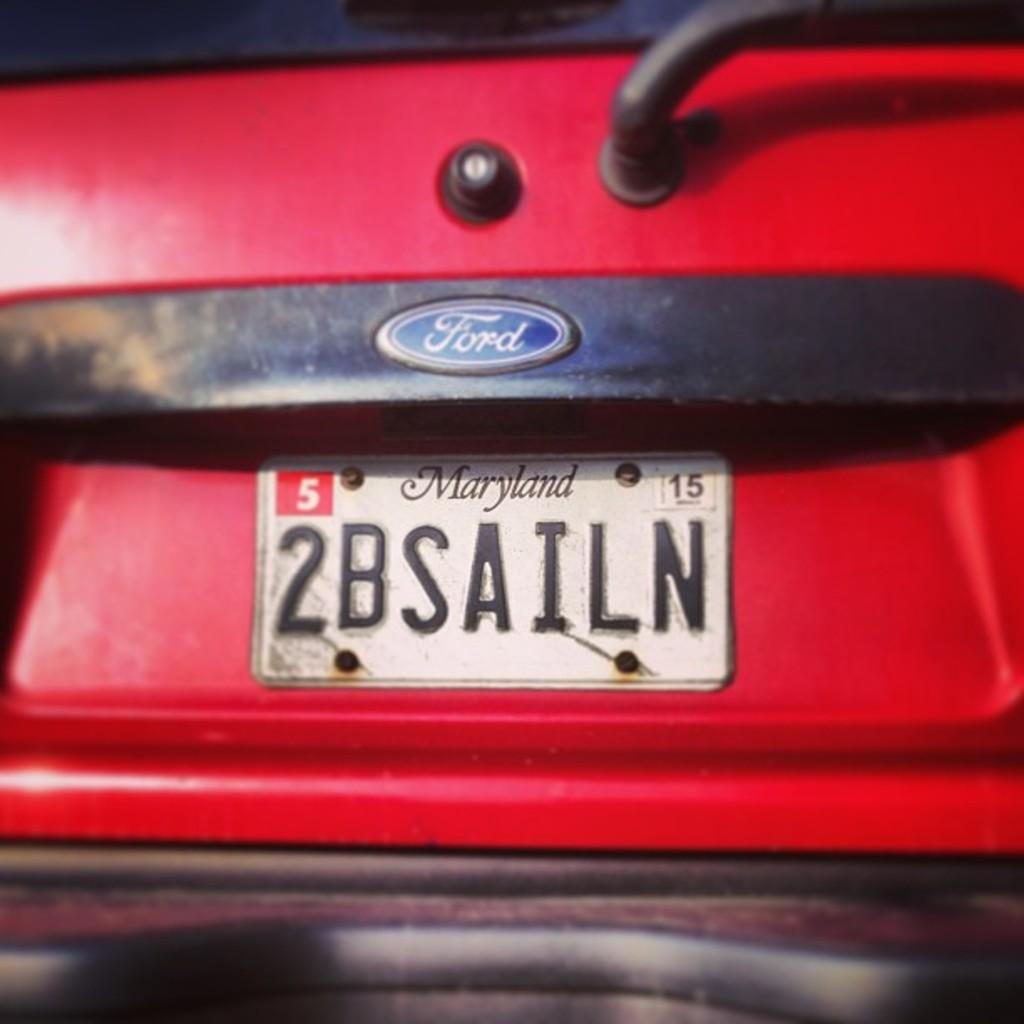<image>
Summarize the visual content of the image. A red ford vehicle with the tag plate 2BSAILN on the back. 